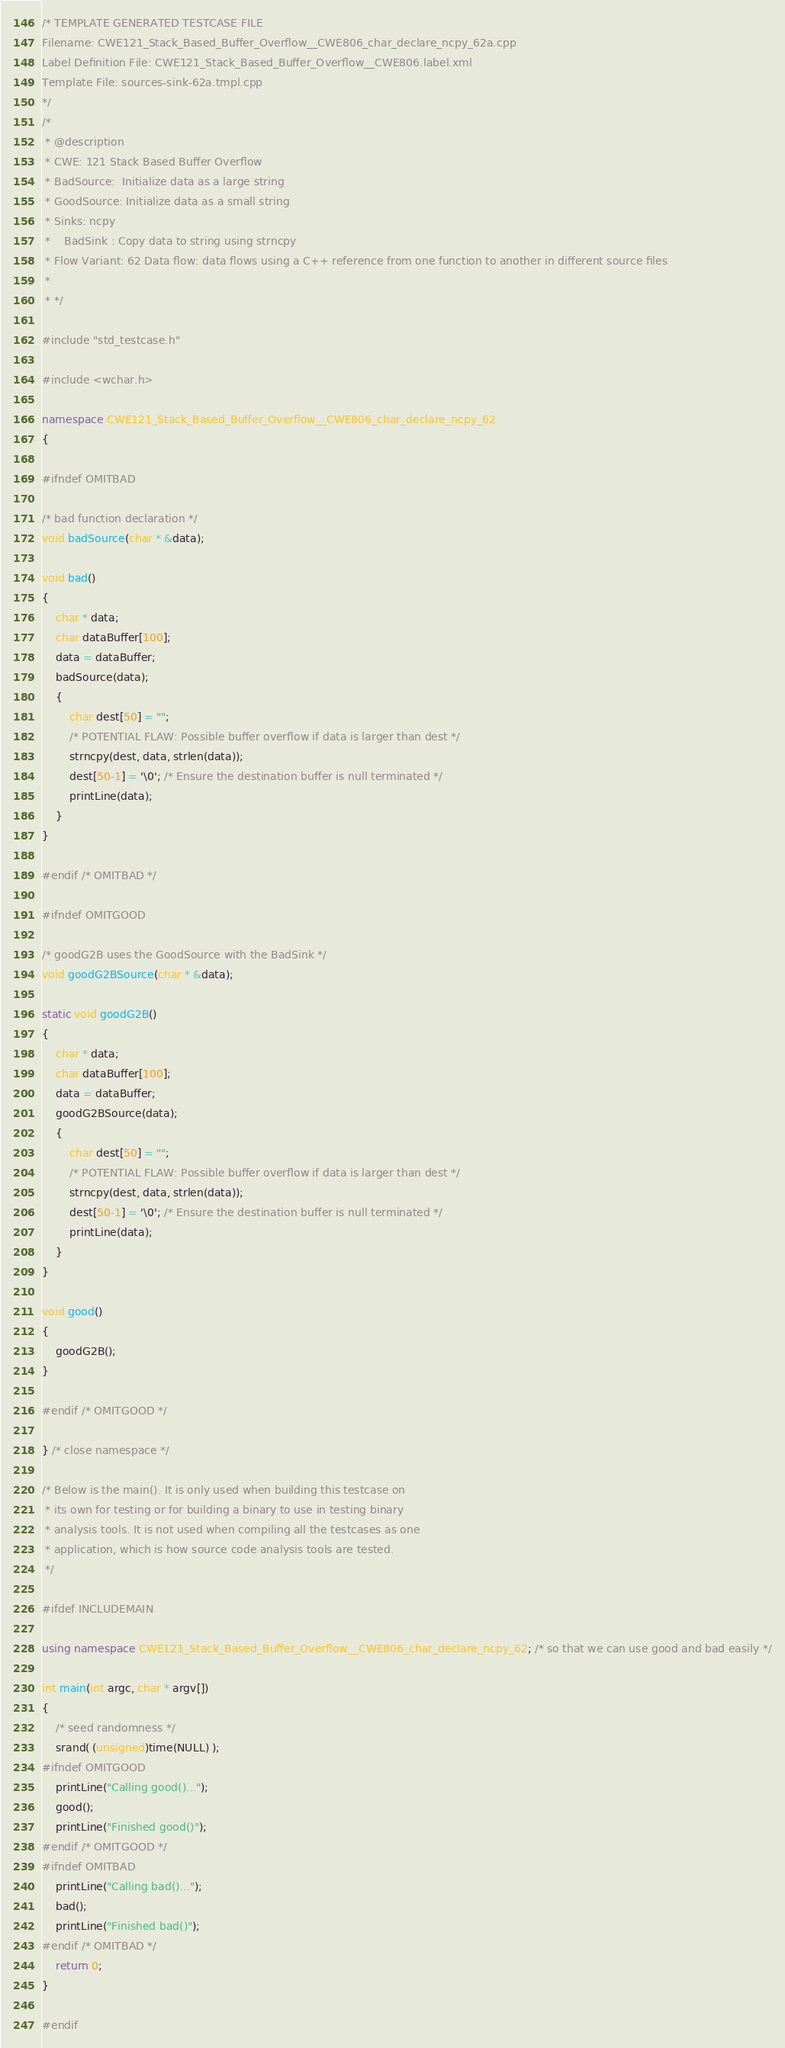<code> <loc_0><loc_0><loc_500><loc_500><_C++_>/* TEMPLATE GENERATED TESTCASE FILE
Filename: CWE121_Stack_Based_Buffer_Overflow__CWE806_char_declare_ncpy_62a.cpp
Label Definition File: CWE121_Stack_Based_Buffer_Overflow__CWE806.label.xml
Template File: sources-sink-62a.tmpl.cpp
*/
/*
 * @description
 * CWE: 121 Stack Based Buffer Overflow
 * BadSource:  Initialize data as a large string
 * GoodSource: Initialize data as a small string
 * Sinks: ncpy
 *    BadSink : Copy data to string using strncpy
 * Flow Variant: 62 Data flow: data flows using a C++ reference from one function to another in different source files
 *
 * */

#include "std_testcase.h"

#include <wchar.h>

namespace CWE121_Stack_Based_Buffer_Overflow__CWE806_char_declare_ncpy_62
{

#ifndef OMITBAD

/* bad function declaration */
void badSource(char * &data);

void bad()
{
    char * data;
    char dataBuffer[100];
    data = dataBuffer;
    badSource(data);
    {
        char dest[50] = "";
        /* POTENTIAL FLAW: Possible buffer overflow if data is larger than dest */
        strncpy(dest, data, strlen(data));
        dest[50-1] = '\0'; /* Ensure the destination buffer is null terminated */
        printLine(data);
    }
}

#endif /* OMITBAD */

#ifndef OMITGOOD

/* goodG2B uses the GoodSource with the BadSink */
void goodG2BSource(char * &data);

static void goodG2B()
{
    char * data;
    char dataBuffer[100];
    data = dataBuffer;
    goodG2BSource(data);
    {
        char dest[50] = "";
        /* POTENTIAL FLAW: Possible buffer overflow if data is larger than dest */
        strncpy(dest, data, strlen(data));
        dest[50-1] = '\0'; /* Ensure the destination buffer is null terminated */
        printLine(data);
    }
}

void good()
{
    goodG2B();
}

#endif /* OMITGOOD */

} /* close namespace */

/* Below is the main(). It is only used when building this testcase on
 * its own for testing or for building a binary to use in testing binary
 * analysis tools. It is not used when compiling all the testcases as one
 * application, which is how source code analysis tools are tested.
 */

#ifdef INCLUDEMAIN

using namespace CWE121_Stack_Based_Buffer_Overflow__CWE806_char_declare_ncpy_62; /* so that we can use good and bad easily */

int main(int argc, char * argv[])
{
    /* seed randomness */
    srand( (unsigned)time(NULL) );
#ifndef OMITGOOD
    printLine("Calling good()...");
    good();
    printLine("Finished good()");
#endif /* OMITGOOD */
#ifndef OMITBAD
    printLine("Calling bad()...");
    bad();
    printLine("Finished bad()");
#endif /* OMITBAD */
    return 0;
}

#endif
</code> 